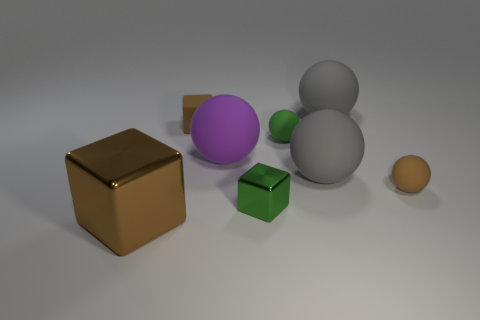Subtract 2 balls. How many balls are left? 3 Subtract all green matte balls. How many balls are left? 4 Subtract all purple balls. How many balls are left? 4 Subtract all cyan balls. Subtract all red cubes. How many balls are left? 5 Add 1 purple things. How many objects exist? 9 Subtract all cubes. How many objects are left? 5 Subtract all green blocks. Subtract all purple spheres. How many objects are left? 6 Add 6 big brown things. How many big brown things are left? 7 Add 2 large purple balls. How many large purple balls exist? 3 Subtract 1 green cubes. How many objects are left? 7 